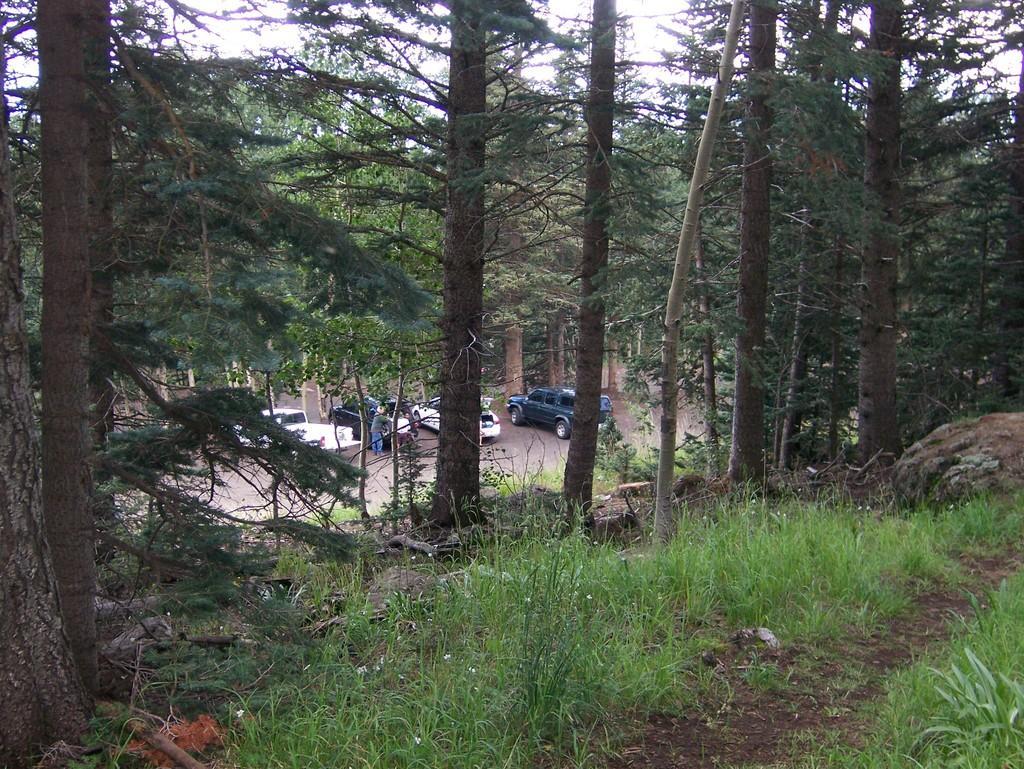Could you give a brief overview of what you see in this image? In this image we can see some vehicles, and persons on the road, there are some trees, plants, grass, also we can see the sky. 